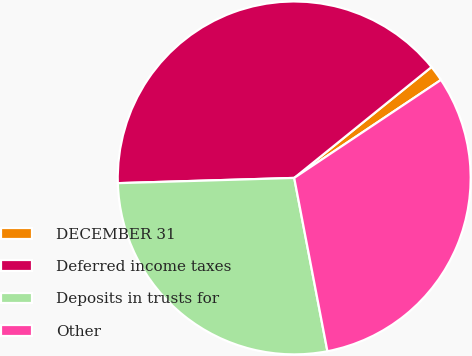Convert chart to OTSL. <chart><loc_0><loc_0><loc_500><loc_500><pie_chart><fcel>DECEMBER 31<fcel>Deferred income taxes<fcel>Deposits in trusts for<fcel>Other<nl><fcel>1.44%<fcel>39.66%<fcel>27.54%<fcel>31.36%<nl></chart> 